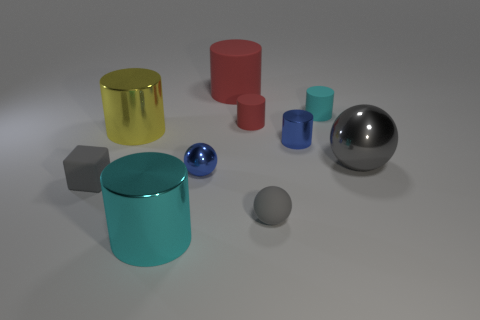Can you describe the setting in which these objects are placed? Certainly! The objects are arranged on what appears to be a flat surface with a subtle reflection, suggesting it might be made of a material like polished concrete or metal. The lighting is soft and diffused, coming from above and creating soft shadows under the objects, enhancing the sense of depth and dimension in the space. 